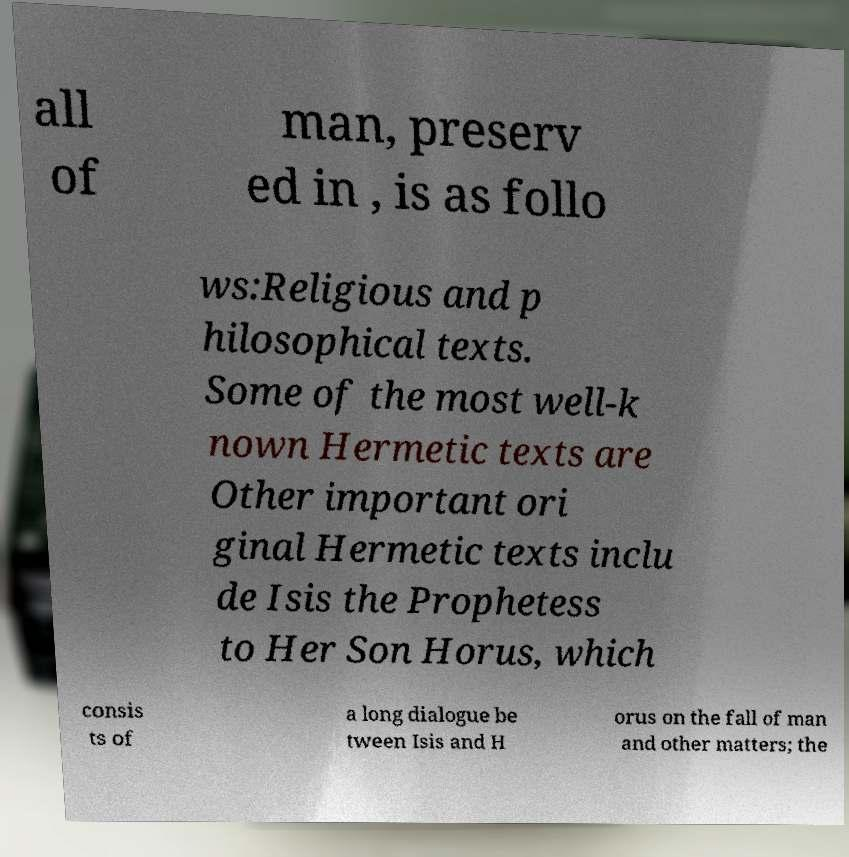Please read and relay the text visible in this image. What does it say? all of man, preserv ed in , is as follo ws:Religious and p hilosophical texts. Some of the most well-k nown Hermetic texts are Other important ori ginal Hermetic texts inclu de Isis the Prophetess to Her Son Horus, which consis ts of a long dialogue be tween Isis and H orus on the fall of man and other matters; the 